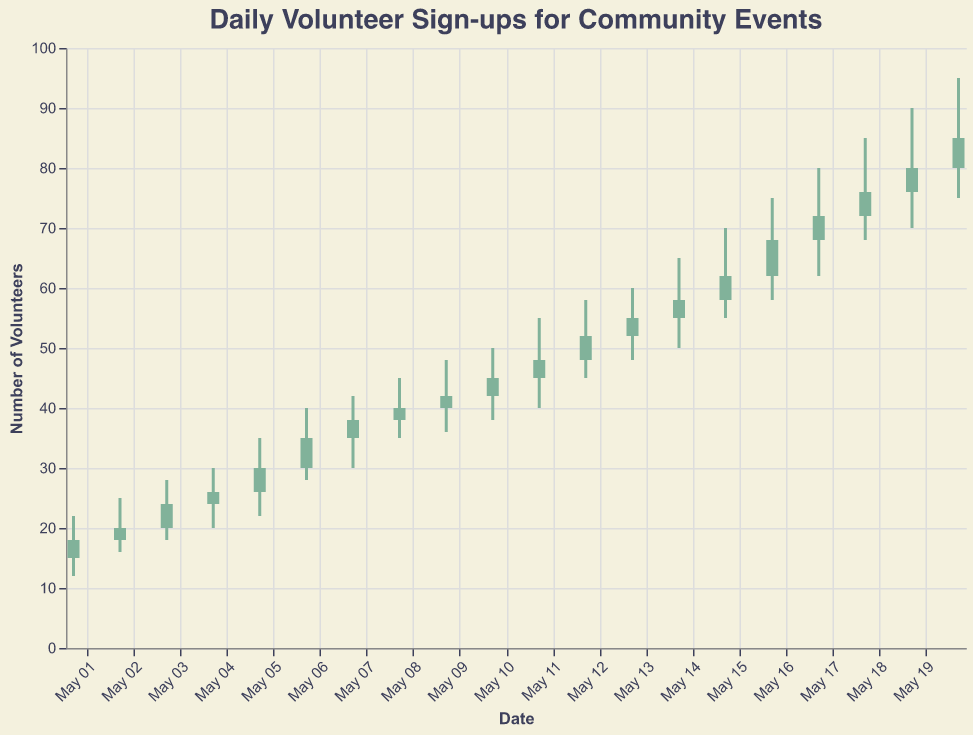What is the highest number of volunteer sign-ups recorded on any single day? The highest number of volunteer sign-ups is represented by the "High" value on each day. By looking at the figure, we can see the highest "High" value is on May 20, which is 95.
Answer: 95 On which date did the volunteer sign-ups open at 58? The figure shows various "Open" values for each date. The date where the "Open" value is 58 is May 15.
Answer: May 15 By how many volunteers did the number of sign-ups increase from May 1 to May 2? The "Close" value on May 1 is 18 and the "Close" value on May 2 is 20. The increase is 20 - 18 = 2.
Answer: 2 Which days have a higher "Close" value than their "Open" value? For each day, if the "Close" value is higher than the "Open" value, it means more volunteers signed up by the end of the day compared to the start. These days can be identified by the bars colored green. They are May 1, May 2, May 3, May 4, May 5, May 6, May 7, May 8, May 9, May 10, May 11, May 12, May 13, May 14, May 15, May 16, May 17, May 18, May 19, and May 20.
Answer: May 1 to May 20 Which date shows the maximum fluctuation in volunteer sign-ups within the day, and what is the amount of this fluctuation? Fluctuation is the difference between the "High" and "Low" values. Checking the data, the maximum fluctuation (High - Low) occurs on May 19 with High = 90 and Low = 70, so 90 - 70 = 20.
Answer: May 19, 20 What is the average number of volunteer sign-ups at the opening time over the given period? Calculate the average of the "Open" values: (15 + 18 + 20 + 24 + 26 + 30 + 35 + 38 + 40 + 42 + 45 + 48 + 52 + 55 + 58 + 62 + 68 + 72 + 76 + 80) / 20 = 44.7
Answer: 44.7 Compare the "Open" and "Close" values on May 10. Is the number of volunteer sign-ups greater or smaller at the closing time? On May 10, the "Open" value is 42 and the "Close" value is 45. Since 45 > 42, the number of volunteer sign-ups is greater at the closing time.
Answer: Greater 